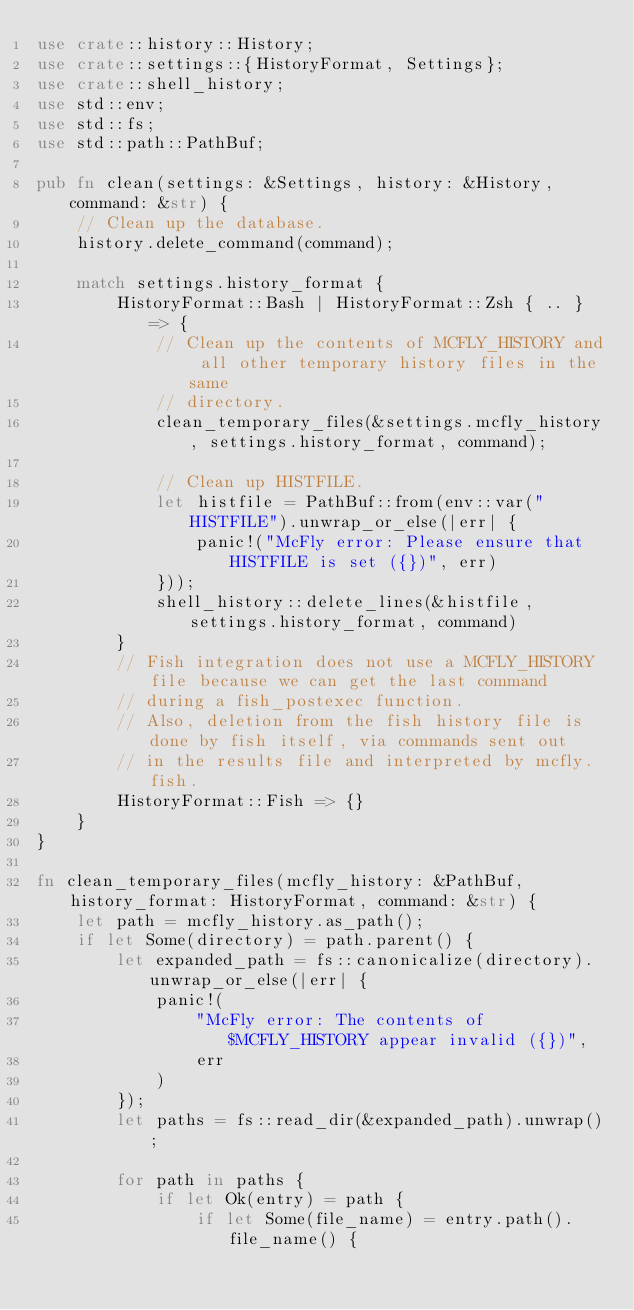Convert code to text. <code><loc_0><loc_0><loc_500><loc_500><_Rust_>use crate::history::History;
use crate::settings::{HistoryFormat, Settings};
use crate::shell_history;
use std::env;
use std::fs;
use std::path::PathBuf;

pub fn clean(settings: &Settings, history: &History, command: &str) {
    // Clean up the database.
    history.delete_command(command);

    match settings.history_format {
        HistoryFormat::Bash | HistoryFormat::Zsh { .. } => {
            // Clean up the contents of MCFLY_HISTORY and all other temporary history files in the same
            // directory.
            clean_temporary_files(&settings.mcfly_history, settings.history_format, command);

            // Clean up HISTFILE.
            let histfile = PathBuf::from(env::var("HISTFILE").unwrap_or_else(|err| {
                panic!("McFly error: Please ensure that HISTFILE is set ({})", err)
            }));
            shell_history::delete_lines(&histfile, settings.history_format, command)
        }
        // Fish integration does not use a MCFLY_HISTORY file because we can get the last command
        // during a fish_postexec function.
        // Also, deletion from the fish history file is done by fish itself, via commands sent out
        // in the results file and interpreted by mcfly.fish.
        HistoryFormat::Fish => {}
    }
}

fn clean_temporary_files(mcfly_history: &PathBuf, history_format: HistoryFormat, command: &str) {
    let path = mcfly_history.as_path();
    if let Some(directory) = path.parent() {
        let expanded_path = fs::canonicalize(directory).unwrap_or_else(|err| {
            panic!(
                "McFly error: The contents of $MCFLY_HISTORY appear invalid ({})",
                err
            )
        });
        let paths = fs::read_dir(&expanded_path).unwrap();

        for path in paths {
            if let Ok(entry) = path {
                if let Some(file_name) = entry.path().file_name() {</code> 